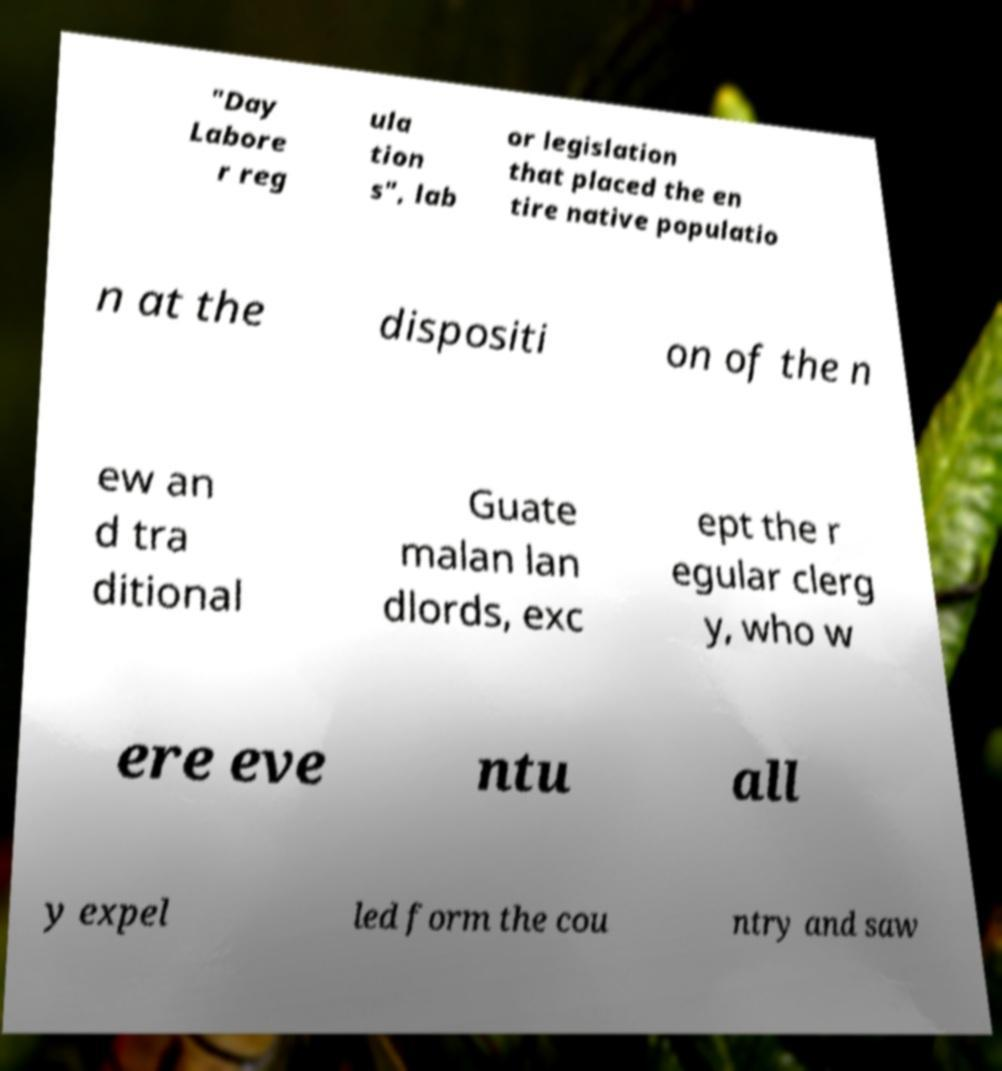Could you extract and type out the text from this image? "Day Labore r reg ula tion s", lab or legislation that placed the en tire native populatio n at the dispositi on of the n ew an d tra ditional Guate malan lan dlords, exc ept the r egular clerg y, who w ere eve ntu all y expel led form the cou ntry and saw 